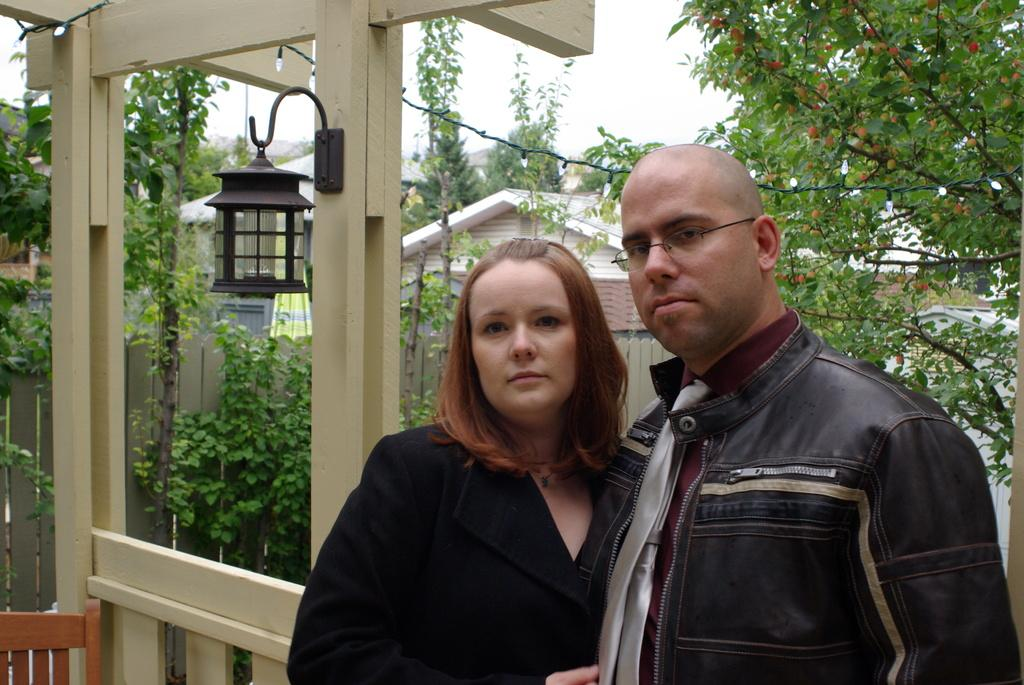What can be seen in the image? There are people standing in the image. What is visible in the background of the image? There are trees and buildings visible in the background of the image. What story is being told by the people in the image? There is no story being told by the people in the image; they are simply standing. 